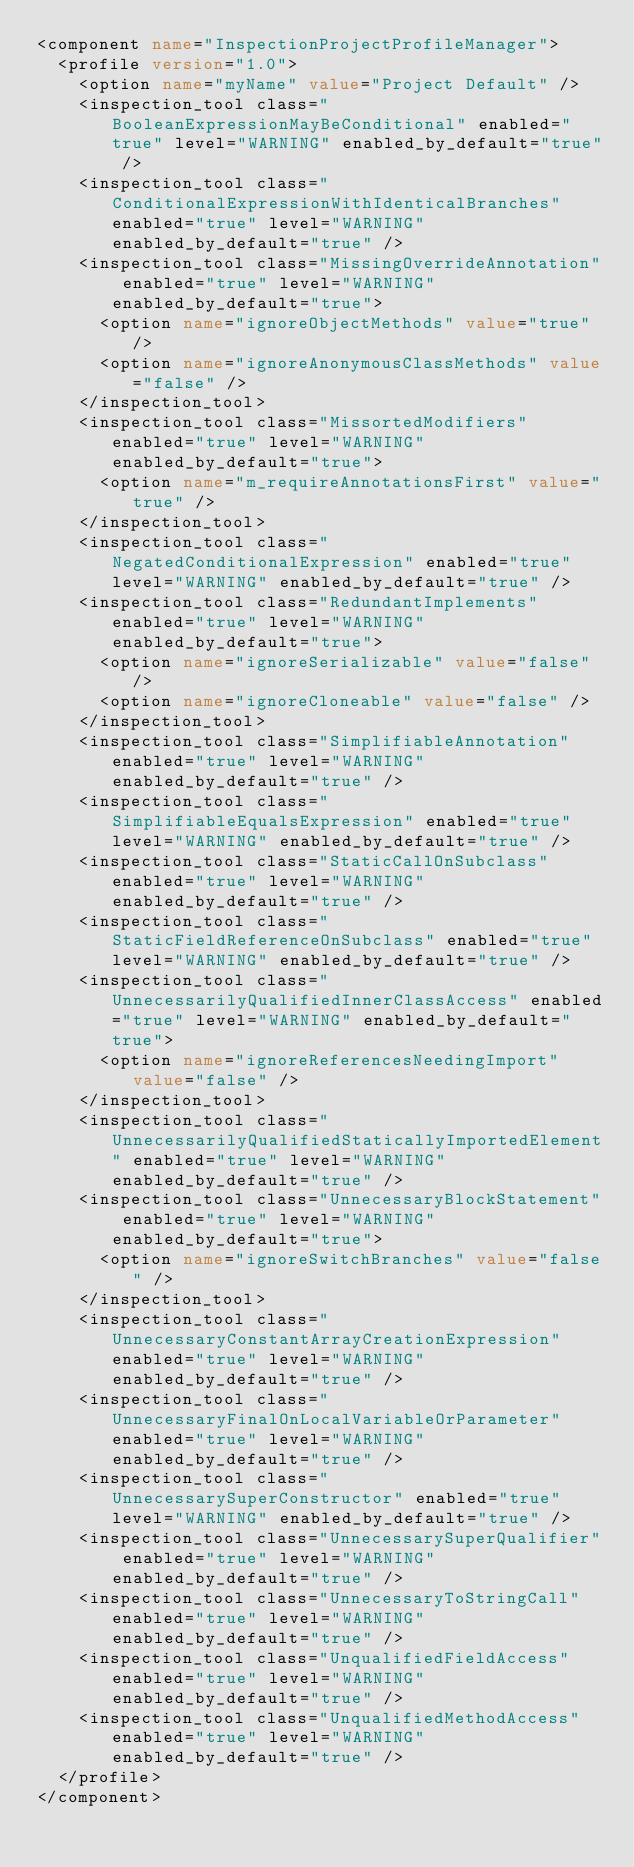Convert code to text. <code><loc_0><loc_0><loc_500><loc_500><_XML_><component name="InspectionProjectProfileManager">
  <profile version="1.0">
    <option name="myName" value="Project Default" />
    <inspection_tool class="BooleanExpressionMayBeConditional" enabled="true" level="WARNING" enabled_by_default="true" />
    <inspection_tool class="ConditionalExpressionWithIdenticalBranches" enabled="true" level="WARNING" enabled_by_default="true" />
    <inspection_tool class="MissingOverrideAnnotation" enabled="true" level="WARNING" enabled_by_default="true">
      <option name="ignoreObjectMethods" value="true" />
      <option name="ignoreAnonymousClassMethods" value="false" />
    </inspection_tool>
    <inspection_tool class="MissortedModifiers" enabled="true" level="WARNING" enabled_by_default="true">
      <option name="m_requireAnnotationsFirst" value="true" />
    </inspection_tool>
    <inspection_tool class="NegatedConditionalExpression" enabled="true" level="WARNING" enabled_by_default="true" />
    <inspection_tool class="RedundantImplements" enabled="true" level="WARNING" enabled_by_default="true">
      <option name="ignoreSerializable" value="false" />
      <option name="ignoreCloneable" value="false" />
    </inspection_tool>
    <inspection_tool class="SimplifiableAnnotation" enabled="true" level="WARNING" enabled_by_default="true" />
    <inspection_tool class="SimplifiableEqualsExpression" enabled="true" level="WARNING" enabled_by_default="true" />
    <inspection_tool class="StaticCallOnSubclass" enabled="true" level="WARNING" enabled_by_default="true" />
    <inspection_tool class="StaticFieldReferenceOnSubclass" enabled="true" level="WARNING" enabled_by_default="true" />
    <inspection_tool class="UnnecessarilyQualifiedInnerClassAccess" enabled="true" level="WARNING" enabled_by_default="true">
      <option name="ignoreReferencesNeedingImport" value="false" />
    </inspection_tool>
    <inspection_tool class="UnnecessarilyQualifiedStaticallyImportedElement" enabled="true" level="WARNING" enabled_by_default="true" />
    <inspection_tool class="UnnecessaryBlockStatement" enabled="true" level="WARNING" enabled_by_default="true">
      <option name="ignoreSwitchBranches" value="false" />
    </inspection_tool>
    <inspection_tool class="UnnecessaryConstantArrayCreationExpression" enabled="true" level="WARNING" enabled_by_default="true" />
    <inspection_tool class="UnnecessaryFinalOnLocalVariableOrParameter" enabled="true" level="WARNING" enabled_by_default="true" />
    <inspection_tool class="UnnecessarySuperConstructor" enabled="true" level="WARNING" enabled_by_default="true" />
    <inspection_tool class="UnnecessarySuperQualifier" enabled="true" level="WARNING" enabled_by_default="true" />
    <inspection_tool class="UnnecessaryToStringCall" enabled="true" level="WARNING" enabled_by_default="true" />
    <inspection_tool class="UnqualifiedFieldAccess" enabled="true" level="WARNING" enabled_by_default="true" />
    <inspection_tool class="UnqualifiedMethodAccess" enabled="true" level="WARNING" enabled_by_default="true" />
  </profile>
</component></code> 